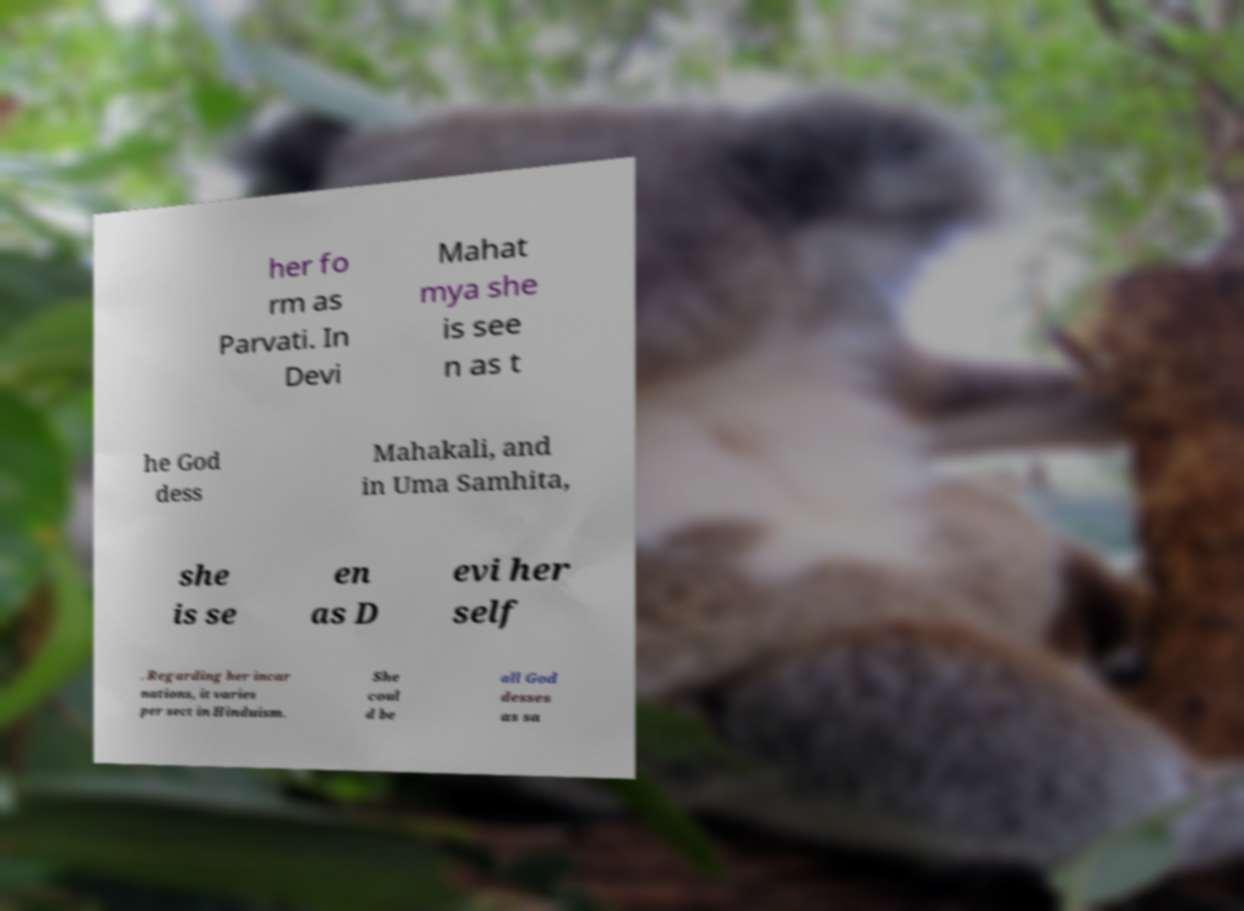Can you read and provide the text displayed in the image?This photo seems to have some interesting text. Can you extract and type it out for me? her fo rm as Parvati. In Devi Mahat mya she is see n as t he God dess Mahakali, and in Uma Samhita, she is se en as D evi her self . Regarding her incar nations, it varies per sect in Hinduism. She coul d be all God desses as sa 